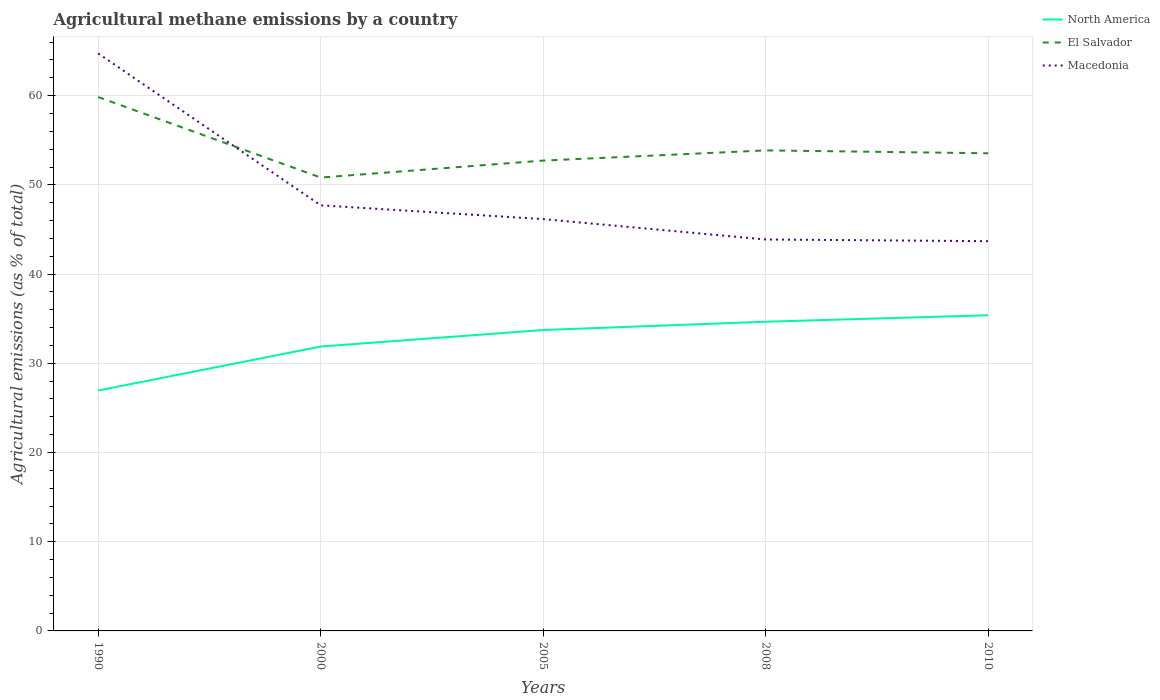Does the line corresponding to North America intersect with the line corresponding to Macedonia?
Keep it short and to the point. No. Is the number of lines equal to the number of legend labels?
Provide a short and direct response. Yes. Across all years, what is the maximum amount of agricultural methane emitted in Macedonia?
Offer a terse response. 43.69. In which year was the amount of agricultural methane emitted in North America maximum?
Your response must be concise. 1990. What is the total amount of agricultural methane emitted in North America in the graph?
Give a very brief answer. -2.78. What is the difference between the highest and the second highest amount of agricultural methane emitted in North America?
Provide a succinct answer. 8.44. What is the difference between the highest and the lowest amount of agricultural methane emitted in North America?
Your response must be concise. 3. How many lines are there?
Ensure brevity in your answer.  3. How many years are there in the graph?
Offer a terse response. 5. Are the values on the major ticks of Y-axis written in scientific E-notation?
Offer a terse response. No. Does the graph contain any zero values?
Your answer should be very brief. No. Does the graph contain grids?
Keep it short and to the point. Yes. What is the title of the graph?
Your answer should be very brief. Agricultural methane emissions by a country. Does "Czech Republic" appear as one of the legend labels in the graph?
Your answer should be very brief. No. What is the label or title of the X-axis?
Your answer should be very brief. Years. What is the label or title of the Y-axis?
Your response must be concise. Agricultural emissions (as % of total). What is the Agricultural emissions (as % of total) in North America in 1990?
Your answer should be very brief. 26.95. What is the Agricultural emissions (as % of total) of El Salvador in 1990?
Your answer should be compact. 59.84. What is the Agricultural emissions (as % of total) of Macedonia in 1990?
Offer a very short reply. 64.73. What is the Agricultural emissions (as % of total) of North America in 2000?
Provide a short and direct response. 31.88. What is the Agricultural emissions (as % of total) in El Salvador in 2000?
Ensure brevity in your answer.  50.82. What is the Agricultural emissions (as % of total) in Macedonia in 2000?
Keep it short and to the point. 47.7. What is the Agricultural emissions (as % of total) in North America in 2005?
Ensure brevity in your answer.  33.73. What is the Agricultural emissions (as % of total) in El Salvador in 2005?
Provide a succinct answer. 52.72. What is the Agricultural emissions (as % of total) in Macedonia in 2005?
Keep it short and to the point. 46.16. What is the Agricultural emissions (as % of total) in North America in 2008?
Ensure brevity in your answer.  34.66. What is the Agricultural emissions (as % of total) of El Salvador in 2008?
Offer a very short reply. 53.86. What is the Agricultural emissions (as % of total) of Macedonia in 2008?
Your answer should be very brief. 43.88. What is the Agricultural emissions (as % of total) of North America in 2010?
Offer a very short reply. 35.38. What is the Agricultural emissions (as % of total) in El Salvador in 2010?
Make the answer very short. 53.54. What is the Agricultural emissions (as % of total) of Macedonia in 2010?
Make the answer very short. 43.69. Across all years, what is the maximum Agricultural emissions (as % of total) of North America?
Ensure brevity in your answer.  35.38. Across all years, what is the maximum Agricultural emissions (as % of total) in El Salvador?
Your response must be concise. 59.84. Across all years, what is the maximum Agricultural emissions (as % of total) of Macedonia?
Provide a short and direct response. 64.73. Across all years, what is the minimum Agricultural emissions (as % of total) in North America?
Keep it short and to the point. 26.95. Across all years, what is the minimum Agricultural emissions (as % of total) of El Salvador?
Make the answer very short. 50.82. Across all years, what is the minimum Agricultural emissions (as % of total) of Macedonia?
Provide a succinct answer. 43.69. What is the total Agricultural emissions (as % of total) in North America in the graph?
Your answer should be compact. 162.59. What is the total Agricultural emissions (as % of total) in El Salvador in the graph?
Provide a succinct answer. 270.78. What is the total Agricultural emissions (as % of total) of Macedonia in the graph?
Keep it short and to the point. 246.16. What is the difference between the Agricultural emissions (as % of total) in North America in 1990 and that in 2000?
Make the answer very short. -4.93. What is the difference between the Agricultural emissions (as % of total) in El Salvador in 1990 and that in 2000?
Keep it short and to the point. 9.02. What is the difference between the Agricultural emissions (as % of total) of Macedonia in 1990 and that in 2000?
Keep it short and to the point. 17.03. What is the difference between the Agricultural emissions (as % of total) of North America in 1990 and that in 2005?
Your answer should be compact. -6.78. What is the difference between the Agricultural emissions (as % of total) of El Salvador in 1990 and that in 2005?
Provide a succinct answer. 7.12. What is the difference between the Agricultural emissions (as % of total) in Macedonia in 1990 and that in 2005?
Give a very brief answer. 18.57. What is the difference between the Agricultural emissions (as % of total) of North America in 1990 and that in 2008?
Provide a short and direct response. -7.71. What is the difference between the Agricultural emissions (as % of total) of El Salvador in 1990 and that in 2008?
Give a very brief answer. 5.98. What is the difference between the Agricultural emissions (as % of total) of Macedonia in 1990 and that in 2008?
Offer a terse response. 20.85. What is the difference between the Agricultural emissions (as % of total) of North America in 1990 and that in 2010?
Provide a short and direct response. -8.44. What is the difference between the Agricultural emissions (as % of total) of El Salvador in 1990 and that in 2010?
Offer a very short reply. 6.3. What is the difference between the Agricultural emissions (as % of total) in Macedonia in 1990 and that in 2010?
Offer a terse response. 21.04. What is the difference between the Agricultural emissions (as % of total) of North America in 2000 and that in 2005?
Give a very brief answer. -1.85. What is the difference between the Agricultural emissions (as % of total) of El Salvador in 2000 and that in 2005?
Your response must be concise. -1.9. What is the difference between the Agricultural emissions (as % of total) in Macedonia in 2000 and that in 2005?
Provide a succinct answer. 1.55. What is the difference between the Agricultural emissions (as % of total) of North America in 2000 and that in 2008?
Your answer should be compact. -2.78. What is the difference between the Agricultural emissions (as % of total) in El Salvador in 2000 and that in 2008?
Provide a succinct answer. -3.04. What is the difference between the Agricultural emissions (as % of total) in Macedonia in 2000 and that in 2008?
Keep it short and to the point. 3.83. What is the difference between the Agricultural emissions (as % of total) of North America in 2000 and that in 2010?
Your answer should be very brief. -3.51. What is the difference between the Agricultural emissions (as % of total) in El Salvador in 2000 and that in 2010?
Make the answer very short. -2.72. What is the difference between the Agricultural emissions (as % of total) in Macedonia in 2000 and that in 2010?
Your answer should be compact. 4.02. What is the difference between the Agricultural emissions (as % of total) of North America in 2005 and that in 2008?
Make the answer very short. -0.93. What is the difference between the Agricultural emissions (as % of total) of El Salvador in 2005 and that in 2008?
Give a very brief answer. -1.14. What is the difference between the Agricultural emissions (as % of total) in Macedonia in 2005 and that in 2008?
Provide a succinct answer. 2.28. What is the difference between the Agricultural emissions (as % of total) in North America in 2005 and that in 2010?
Ensure brevity in your answer.  -1.65. What is the difference between the Agricultural emissions (as % of total) in El Salvador in 2005 and that in 2010?
Offer a terse response. -0.82. What is the difference between the Agricultural emissions (as % of total) of Macedonia in 2005 and that in 2010?
Offer a very short reply. 2.47. What is the difference between the Agricultural emissions (as % of total) in North America in 2008 and that in 2010?
Ensure brevity in your answer.  -0.72. What is the difference between the Agricultural emissions (as % of total) in El Salvador in 2008 and that in 2010?
Provide a short and direct response. 0.32. What is the difference between the Agricultural emissions (as % of total) of Macedonia in 2008 and that in 2010?
Keep it short and to the point. 0.19. What is the difference between the Agricultural emissions (as % of total) of North America in 1990 and the Agricultural emissions (as % of total) of El Salvador in 2000?
Give a very brief answer. -23.87. What is the difference between the Agricultural emissions (as % of total) in North America in 1990 and the Agricultural emissions (as % of total) in Macedonia in 2000?
Your response must be concise. -20.76. What is the difference between the Agricultural emissions (as % of total) in El Salvador in 1990 and the Agricultural emissions (as % of total) in Macedonia in 2000?
Your response must be concise. 12.14. What is the difference between the Agricultural emissions (as % of total) of North America in 1990 and the Agricultural emissions (as % of total) of El Salvador in 2005?
Keep it short and to the point. -25.77. What is the difference between the Agricultural emissions (as % of total) of North America in 1990 and the Agricultural emissions (as % of total) of Macedonia in 2005?
Offer a terse response. -19.21. What is the difference between the Agricultural emissions (as % of total) in El Salvador in 1990 and the Agricultural emissions (as % of total) in Macedonia in 2005?
Offer a very short reply. 13.68. What is the difference between the Agricultural emissions (as % of total) in North America in 1990 and the Agricultural emissions (as % of total) in El Salvador in 2008?
Offer a very short reply. -26.92. What is the difference between the Agricultural emissions (as % of total) in North America in 1990 and the Agricultural emissions (as % of total) in Macedonia in 2008?
Your answer should be compact. -16.93. What is the difference between the Agricultural emissions (as % of total) of El Salvador in 1990 and the Agricultural emissions (as % of total) of Macedonia in 2008?
Your response must be concise. 15.97. What is the difference between the Agricultural emissions (as % of total) of North America in 1990 and the Agricultural emissions (as % of total) of El Salvador in 2010?
Make the answer very short. -26.59. What is the difference between the Agricultural emissions (as % of total) in North America in 1990 and the Agricultural emissions (as % of total) in Macedonia in 2010?
Provide a succinct answer. -16.74. What is the difference between the Agricultural emissions (as % of total) of El Salvador in 1990 and the Agricultural emissions (as % of total) of Macedonia in 2010?
Give a very brief answer. 16.15. What is the difference between the Agricultural emissions (as % of total) in North America in 2000 and the Agricultural emissions (as % of total) in El Salvador in 2005?
Ensure brevity in your answer.  -20.84. What is the difference between the Agricultural emissions (as % of total) in North America in 2000 and the Agricultural emissions (as % of total) in Macedonia in 2005?
Ensure brevity in your answer.  -14.28. What is the difference between the Agricultural emissions (as % of total) in El Salvador in 2000 and the Agricultural emissions (as % of total) in Macedonia in 2005?
Keep it short and to the point. 4.66. What is the difference between the Agricultural emissions (as % of total) of North America in 2000 and the Agricultural emissions (as % of total) of El Salvador in 2008?
Offer a terse response. -21.98. What is the difference between the Agricultural emissions (as % of total) in North America in 2000 and the Agricultural emissions (as % of total) in Macedonia in 2008?
Give a very brief answer. -12. What is the difference between the Agricultural emissions (as % of total) of El Salvador in 2000 and the Agricultural emissions (as % of total) of Macedonia in 2008?
Offer a terse response. 6.94. What is the difference between the Agricultural emissions (as % of total) of North America in 2000 and the Agricultural emissions (as % of total) of El Salvador in 2010?
Make the answer very short. -21.66. What is the difference between the Agricultural emissions (as % of total) in North America in 2000 and the Agricultural emissions (as % of total) in Macedonia in 2010?
Provide a succinct answer. -11.81. What is the difference between the Agricultural emissions (as % of total) in El Salvador in 2000 and the Agricultural emissions (as % of total) in Macedonia in 2010?
Make the answer very short. 7.13. What is the difference between the Agricultural emissions (as % of total) in North America in 2005 and the Agricultural emissions (as % of total) in El Salvador in 2008?
Your response must be concise. -20.13. What is the difference between the Agricultural emissions (as % of total) of North America in 2005 and the Agricultural emissions (as % of total) of Macedonia in 2008?
Give a very brief answer. -10.15. What is the difference between the Agricultural emissions (as % of total) of El Salvador in 2005 and the Agricultural emissions (as % of total) of Macedonia in 2008?
Your response must be concise. 8.84. What is the difference between the Agricultural emissions (as % of total) of North America in 2005 and the Agricultural emissions (as % of total) of El Salvador in 2010?
Make the answer very short. -19.81. What is the difference between the Agricultural emissions (as % of total) of North America in 2005 and the Agricultural emissions (as % of total) of Macedonia in 2010?
Make the answer very short. -9.96. What is the difference between the Agricultural emissions (as % of total) of El Salvador in 2005 and the Agricultural emissions (as % of total) of Macedonia in 2010?
Make the answer very short. 9.03. What is the difference between the Agricultural emissions (as % of total) in North America in 2008 and the Agricultural emissions (as % of total) in El Salvador in 2010?
Your answer should be very brief. -18.88. What is the difference between the Agricultural emissions (as % of total) in North America in 2008 and the Agricultural emissions (as % of total) in Macedonia in 2010?
Keep it short and to the point. -9.03. What is the difference between the Agricultural emissions (as % of total) of El Salvador in 2008 and the Agricultural emissions (as % of total) of Macedonia in 2010?
Provide a succinct answer. 10.17. What is the average Agricultural emissions (as % of total) in North America per year?
Keep it short and to the point. 32.52. What is the average Agricultural emissions (as % of total) in El Salvador per year?
Offer a very short reply. 54.16. What is the average Agricultural emissions (as % of total) in Macedonia per year?
Provide a succinct answer. 49.23. In the year 1990, what is the difference between the Agricultural emissions (as % of total) of North America and Agricultural emissions (as % of total) of El Salvador?
Your answer should be compact. -32.9. In the year 1990, what is the difference between the Agricultural emissions (as % of total) of North America and Agricultural emissions (as % of total) of Macedonia?
Give a very brief answer. -37.78. In the year 1990, what is the difference between the Agricultural emissions (as % of total) in El Salvador and Agricultural emissions (as % of total) in Macedonia?
Ensure brevity in your answer.  -4.89. In the year 2000, what is the difference between the Agricultural emissions (as % of total) of North America and Agricultural emissions (as % of total) of El Salvador?
Ensure brevity in your answer.  -18.94. In the year 2000, what is the difference between the Agricultural emissions (as % of total) in North America and Agricultural emissions (as % of total) in Macedonia?
Ensure brevity in your answer.  -15.83. In the year 2000, what is the difference between the Agricultural emissions (as % of total) of El Salvador and Agricultural emissions (as % of total) of Macedonia?
Ensure brevity in your answer.  3.11. In the year 2005, what is the difference between the Agricultural emissions (as % of total) in North America and Agricultural emissions (as % of total) in El Salvador?
Keep it short and to the point. -18.99. In the year 2005, what is the difference between the Agricultural emissions (as % of total) in North America and Agricultural emissions (as % of total) in Macedonia?
Provide a short and direct response. -12.43. In the year 2005, what is the difference between the Agricultural emissions (as % of total) in El Salvador and Agricultural emissions (as % of total) in Macedonia?
Ensure brevity in your answer.  6.56. In the year 2008, what is the difference between the Agricultural emissions (as % of total) in North America and Agricultural emissions (as % of total) in El Salvador?
Offer a very short reply. -19.2. In the year 2008, what is the difference between the Agricultural emissions (as % of total) of North America and Agricultural emissions (as % of total) of Macedonia?
Offer a very short reply. -9.22. In the year 2008, what is the difference between the Agricultural emissions (as % of total) of El Salvador and Agricultural emissions (as % of total) of Macedonia?
Your response must be concise. 9.99. In the year 2010, what is the difference between the Agricultural emissions (as % of total) in North America and Agricultural emissions (as % of total) in El Salvador?
Provide a succinct answer. -18.16. In the year 2010, what is the difference between the Agricultural emissions (as % of total) in North America and Agricultural emissions (as % of total) in Macedonia?
Offer a terse response. -8.3. In the year 2010, what is the difference between the Agricultural emissions (as % of total) in El Salvador and Agricultural emissions (as % of total) in Macedonia?
Provide a short and direct response. 9.85. What is the ratio of the Agricultural emissions (as % of total) in North America in 1990 to that in 2000?
Offer a very short reply. 0.85. What is the ratio of the Agricultural emissions (as % of total) of El Salvador in 1990 to that in 2000?
Your answer should be compact. 1.18. What is the ratio of the Agricultural emissions (as % of total) in Macedonia in 1990 to that in 2000?
Give a very brief answer. 1.36. What is the ratio of the Agricultural emissions (as % of total) of North America in 1990 to that in 2005?
Your answer should be very brief. 0.8. What is the ratio of the Agricultural emissions (as % of total) of El Salvador in 1990 to that in 2005?
Provide a short and direct response. 1.14. What is the ratio of the Agricultural emissions (as % of total) in Macedonia in 1990 to that in 2005?
Give a very brief answer. 1.4. What is the ratio of the Agricultural emissions (as % of total) in North America in 1990 to that in 2008?
Make the answer very short. 0.78. What is the ratio of the Agricultural emissions (as % of total) of El Salvador in 1990 to that in 2008?
Keep it short and to the point. 1.11. What is the ratio of the Agricultural emissions (as % of total) in Macedonia in 1990 to that in 2008?
Give a very brief answer. 1.48. What is the ratio of the Agricultural emissions (as % of total) in North America in 1990 to that in 2010?
Make the answer very short. 0.76. What is the ratio of the Agricultural emissions (as % of total) in El Salvador in 1990 to that in 2010?
Ensure brevity in your answer.  1.12. What is the ratio of the Agricultural emissions (as % of total) of Macedonia in 1990 to that in 2010?
Provide a short and direct response. 1.48. What is the ratio of the Agricultural emissions (as % of total) in North America in 2000 to that in 2005?
Your answer should be compact. 0.95. What is the ratio of the Agricultural emissions (as % of total) in El Salvador in 2000 to that in 2005?
Make the answer very short. 0.96. What is the ratio of the Agricultural emissions (as % of total) in Macedonia in 2000 to that in 2005?
Keep it short and to the point. 1.03. What is the ratio of the Agricultural emissions (as % of total) in North America in 2000 to that in 2008?
Offer a very short reply. 0.92. What is the ratio of the Agricultural emissions (as % of total) in El Salvador in 2000 to that in 2008?
Your answer should be compact. 0.94. What is the ratio of the Agricultural emissions (as % of total) of Macedonia in 2000 to that in 2008?
Your answer should be very brief. 1.09. What is the ratio of the Agricultural emissions (as % of total) of North America in 2000 to that in 2010?
Provide a short and direct response. 0.9. What is the ratio of the Agricultural emissions (as % of total) in El Salvador in 2000 to that in 2010?
Give a very brief answer. 0.95. What is the ratio of the Agricultural emissions (as % of total) in Macedonia in 2000 to that in 2010?
Your answer should be very brief. 1.09. What is the ratio of the Agricultural emissions (as % of total) in North America in 2005 to that in 2008?
Offer a terse response. 0.97. What is the ratio of the Agricultural emissions (as % of total) of El Salvador in 2005 to that in 2008?
Offer a terse response. 0.98. What is the ratio of the Agricultural emissions (as % of total) of Macedonia in 2005 to that in 2008?
Offer a very short reply. 1.05. What is the ratio of the Agricultural emissions (as % of total) in North America in 2005 to that in 2010?
Provide a succinct answer. 0.95. What is the ratio of the Agricultural emissions (as % of total) in El Salvador in 2005 to that in 2010?
Your answer should be very brief. 0.98. What is the ratio of the Agricultural emissions (as % of total) of Macedonia in 2005 to that in 2010?
Offer a very short reply. 1.06. What is the ratio of the Agricultural emissions (as % of total) of North America in 2008 to that in 2010?
Your answer should be very brief. 0.98. What is the ratio of the Agricultural emissions (as % of total) in El Salvador in 2008 to that in 2010?
Your answer should be compact. 1.01. What is the difference between the highest and the second highest Agricultural emissions (as % of total) in North America?
Ensure brevity in your answer.  0.72. What is the difference between the highest and the second highest Agricultural emissions (as % of total) of El Salvador?
Provide a short and direct response. 5.98. What is the difference between the highest and the second highest Agricultural emissions (as % of total) in Macedonia?
Provide a succinct answer. 17.03. What is the difference between the highest and the lowest Agricultural emissions (as % of total) of North America?
Offer a very short reply. 8.44. What is the difference between the highest and the lowest Agricultural emissions (as % of total) of El Salvador?
Your answer should be compact. 9.02. What is the difference between the highest and the lowest Agricultural emissions (as % of total) of Macedonia?
Ensure brevity in your answer.  21.04. 